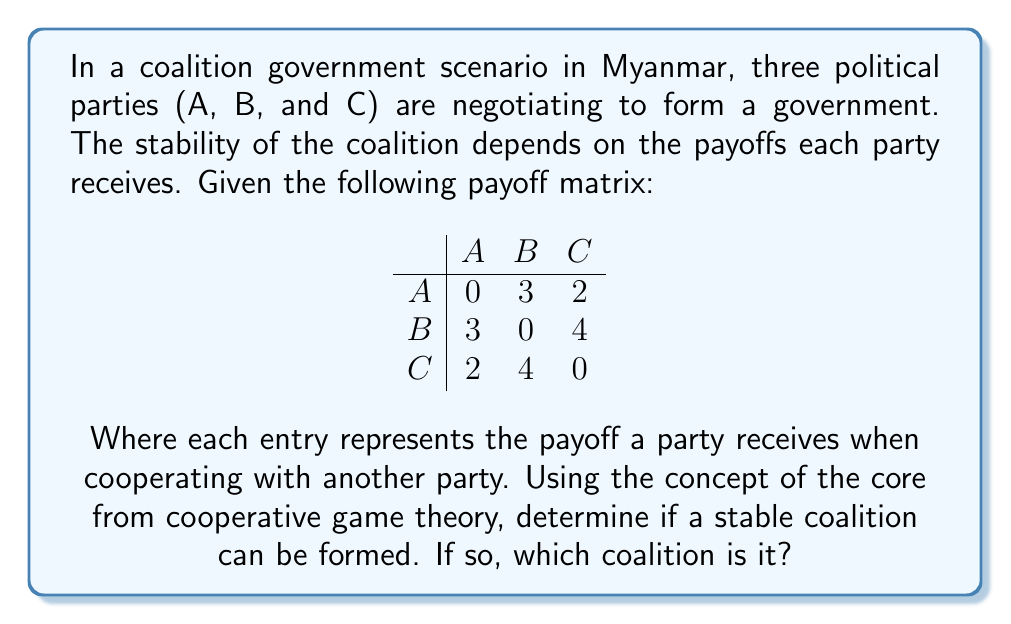Teach me how to tackle this problem. To solve this problem, we'll use the concept of the core from cooperative game theory:

1. First, we need to calculate the value of each possible coalition:
   - $v(A) = v(B) = v(C) = 0$ (single-party coalitions)
   - $v(AB) = 3 + 3 = 6$
   - $v(AC) = 2 + 2 = 4$
   - $v(BC) = 4 + 4 = 8$
   - $v(ABC) = \max(v(AB), v(AC), v(BC)) = 8$

2. For a coalition to be in the core, it must satisfy two conditions:
   a) The total payoff must equal $v(ABC) = 8$
   b) No subset of players can improve their payoff by forming a different coalition

3. Let's consider the grand coalition ABC with payoffs $(x_A, x_B, x_C)$:
   - $x_A + x_B + x_C = 8$ (efficiency condition)
   - $x_A + x_B \geq 6$ (AB coalition constraint)
   - $x_A + x_C \geq 4$ (AC coalition constraint)
   - $x_B + x_C \geq 8$ (BC coalition constraint)

4. From the BC coalition constraint, we can see that $x_B + x_C = 8$, which implies $x_A = 0$.

5. This means the only possible stable allocation is $(0, 4, 4)$.

6. We need to check if this allocation satisfies all constraints:
   - $0 + 4 + 4 = 8$ (satisfies efficiency)
   - $0 + 4 = 4 < 6$ (violates AB coalition constraint)

Therefore, there is no allocation that satisfies all constraints, and the core is empty.
Answer: No stable coalition; core is empty 